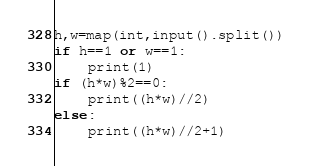Convert code to text. <code><loc_0><loc_0><loc_500><loc_500><_Python_>h,w=map(int,input().split())
if h==1 or w==1:
    print(1)
if (h*w)%2==0:
    print((h*w)//2)
else:
    print((h*w)//2+1)</code> 